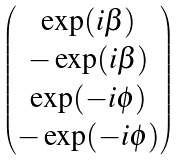Convert formula to latex. <formula><loc_0><loc_0><loc_500><loc_500>\begin{pmatrix} \exp ( i \beta ) \\ - \exp ( i \beta ) \\ \exp ( - i \phi ) \\ - \exp ( - i \phi ) \end{pmatrix}</formula> 